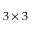Convert formula to latex. <formula><loc_0><loc_0><loc_500><loc_500>3 \times 3</formula> 